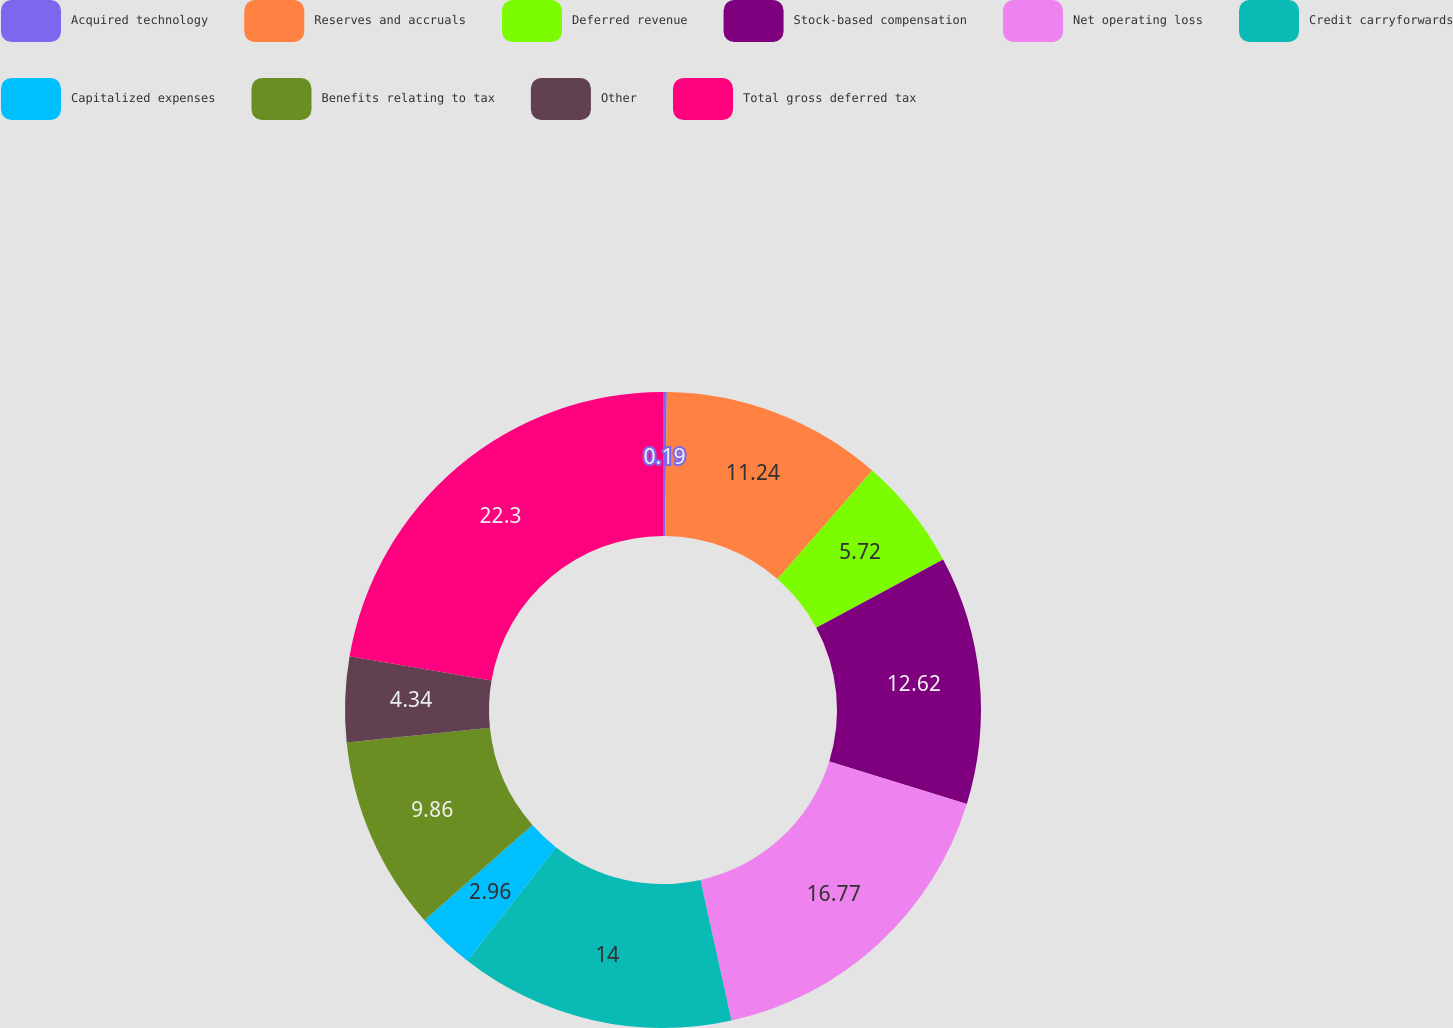<chart> <loc_0><loc_0><loc_500><loc_500><pie_chart><fcel>Acquired technology<fcel>Reserves and accruals<fcel>Deferred revenue<fcel>Stock-based compensation<fcel>Net operating loss<fcel>Credit carryforwards<fcel>Capitalized expenses<fcel>Benefits relating to tax<fcel>Other<fcel>Total gross deferred tax<nl><fcel>0.19%<fcel>11.24%<fcel>5.72%<fcel>12.62%<fcel>16.77%<fcel>14.0%<fcel>2.96%<fcel>9.86%<fcel>4.34%<fcel>22.29%<nl></chart> 